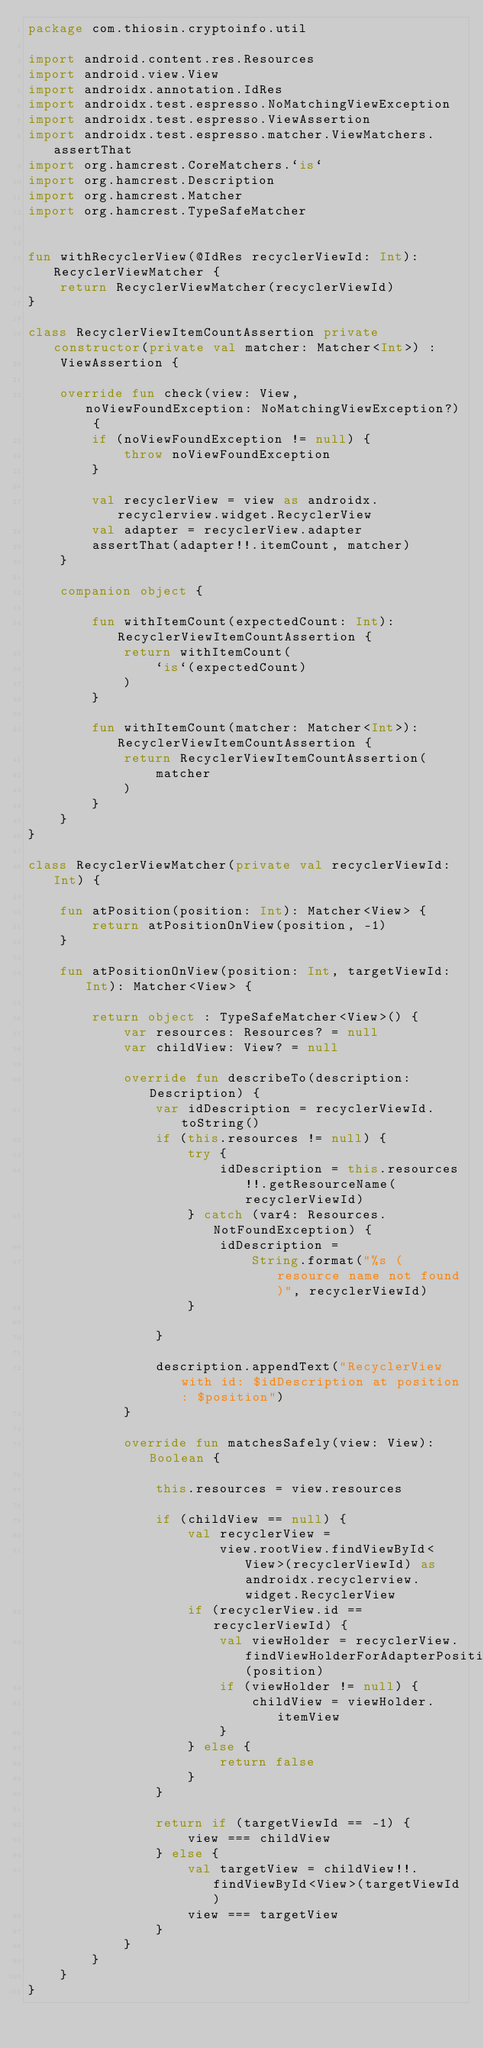<code> <loc_0><loc_0><loc_500><loc_500><_Kotlin_>package com.thiosin.cryptoinfo.util

import android.content.res.Resources
import android.view.View
import androidx.annotation.IdRes
import androidx.test.espresso.NoMatchingViewException
import androidx.test.espresso.ViewAssertion
import androidx.test.espresso.matcher.ViewMatchers.assertThat
import org.hamcrest.CoreMatchers.`is`
import org.hamcrest.Description
import org.hamcrest.Matcher
import org.hamcrest.TypeSafeMatcher


fun withRecyclerView(@IdRes recyclerViewId: Int): RecyclerViewMatcher {
    return RecyclerViewMatcher(recyclerViewId)
}

class RecyclerViewItemCountAssertion private constructor(private val matcher: Matcher<Int>) :
    ViewAssertion {

    override fun check(view: View, noViewFoundException: NoMatchingViewException?) {
        if (noViewFoundException != null) {
            throw noViewFoundException
        }

        val recyclerView = view as androidx.recyclerview.widget.RecyclerView
        val adapter = recyclerView.adapter
        assertThat(adapter!!.itemCount, matcher)
    }

    companion object {

        fun withItemCount(expectedCount: Int): RecyclerViewItemCountAssertion {
            return withItemCount(
                `is`(expectedCount)
            )
        }

        fun withItemCount(matcher: Matcher<Int>): RecyclerViewItemCountAssertion {
            return RecyclerViewItemCountAssertion(
                matcher
            )
        }
    }
}

class RecyclerViewMatcher(private val recyclerViewId: Int) {

    fun atPosition(position: Int): Matcher<View> {
        return atPositionOnView(position, -1)
    }

    fun atPositionOnView(position: Int, targetViewId: Int): Matcher<View> {

        return object : TypeSafeMatcher<View>() {
            var resources: Resources? = null
            var childView: View? = null

            override fun describeTo(description: Description) {
                var idDescription = recyclerViewId.toString()
                if (this.resources != null) {
                    try {
                        idDescription = this.resources!!.getResourceName(recyclerViewId)
                    } catch (var4: Resources.NotFoundException) {
                        idDescription =
                            String.format("%s (resource name not found)", recyclerViewId)
                    }

                }

                description.appendText("RecyclerView with id: $idDescription at position: $position")
            }

            override fun matchesSafely(view: View): Boolean {

                this.resources = view.resources

                if (childView == null) {
                    val recyclerView =
                        view.rootView.findViewById<View>(recyclerViewId) as androidx.recyclerview.widget.RecyclerView
                    if (recyclerView.id == recyclerViewId) {
                        val viewHolder = recyclerView.findViewHolderForAdapterPosition(position)
                        if (viewHolder != null) {
                            childView = viewHolder.itemView
                        }
                    } else {
                        return false
                    }
                }

                return if (targetViewId == -1) {
                    view === childView
                } else {
                    val targetView = childView!!.findViewById<View>(targetViewId)
                    view === targetView
                }
            }
        }
    }
}
</code> 